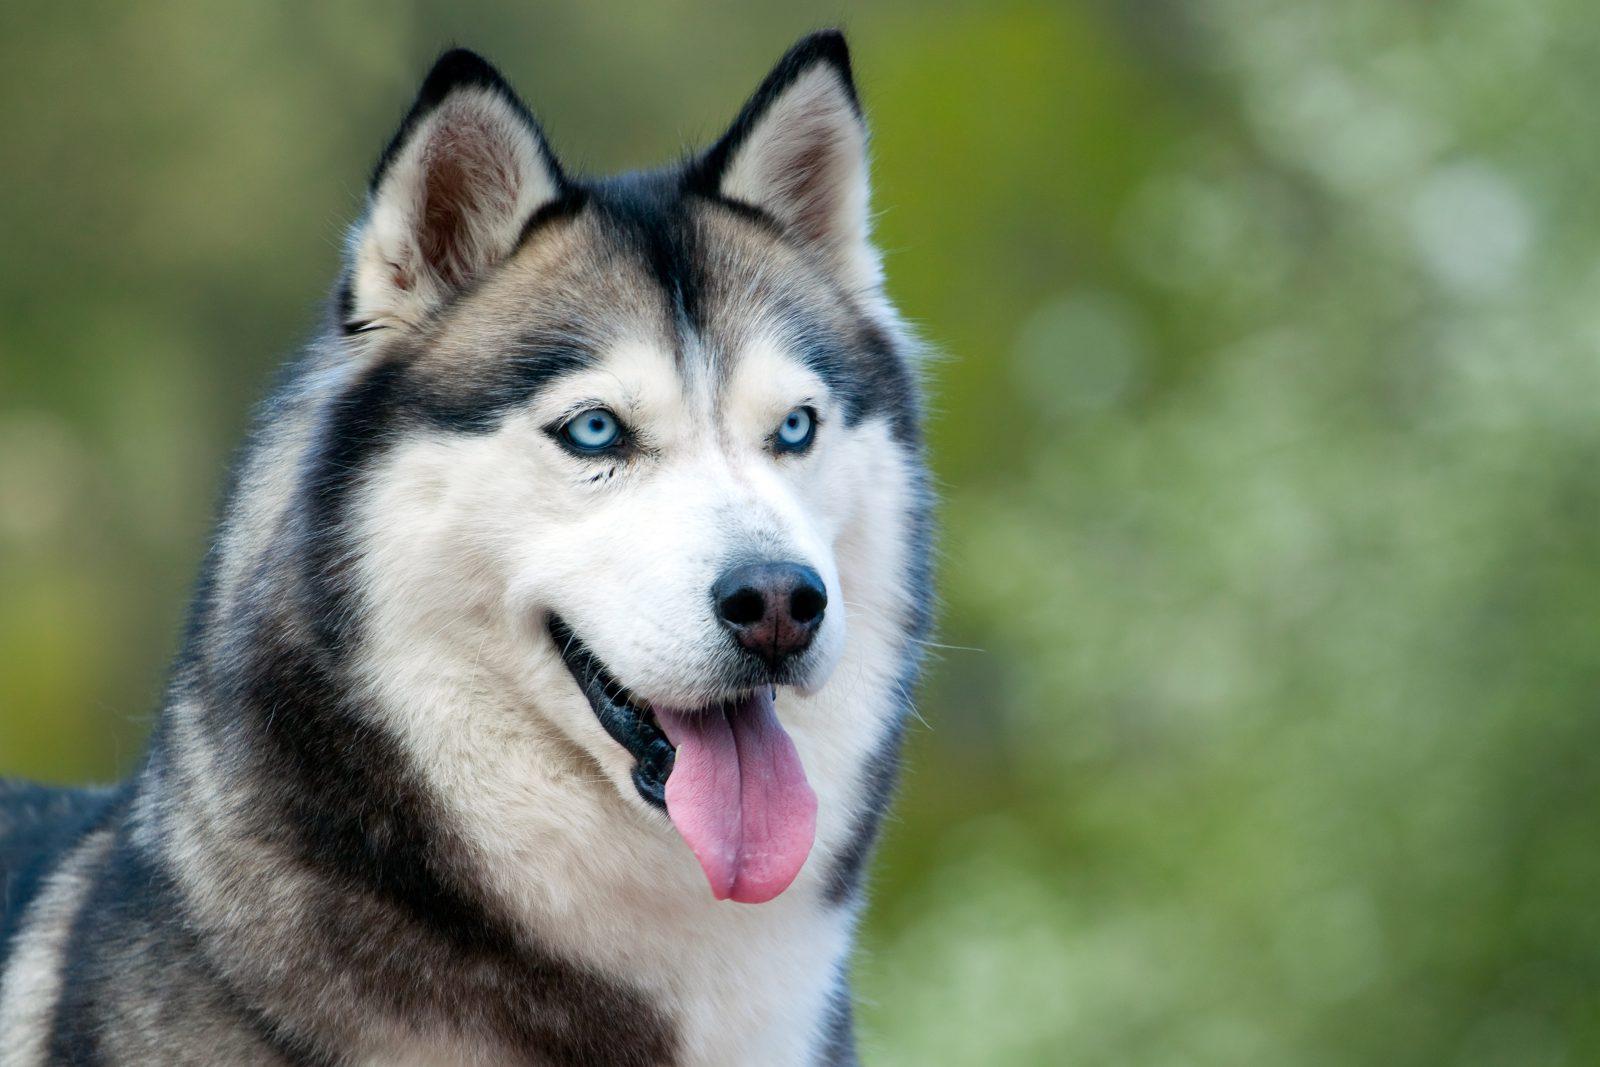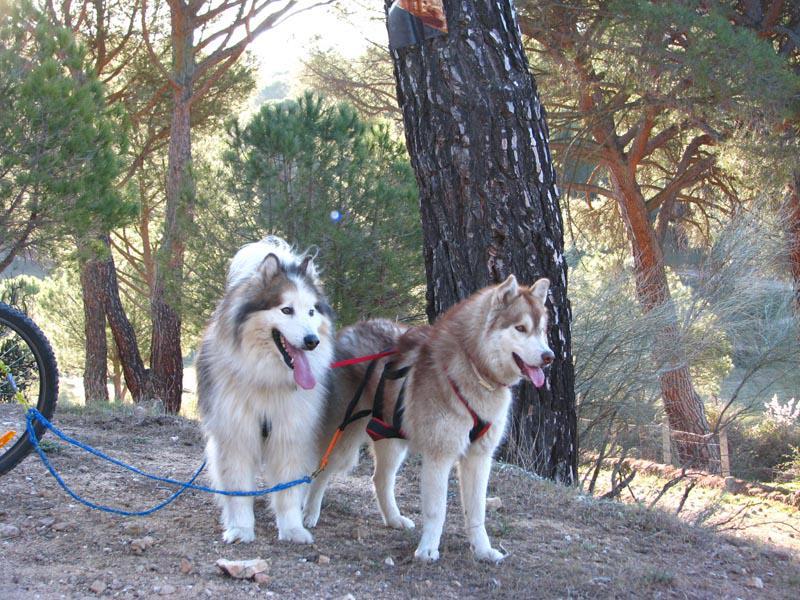The first image is the image on the left, the second image is the image on the right. Assess this claim about the two images: "In one of the images, two malamutes are sitting in the grass.". Correct or not? Answer yes or no. No. The first image is the image on the left, the second image is the image on the right. For the images shown, is this caption "At least one photo has two dogs, and at least three dogs have their mouths open." true? Answer yes or no. Yes. 